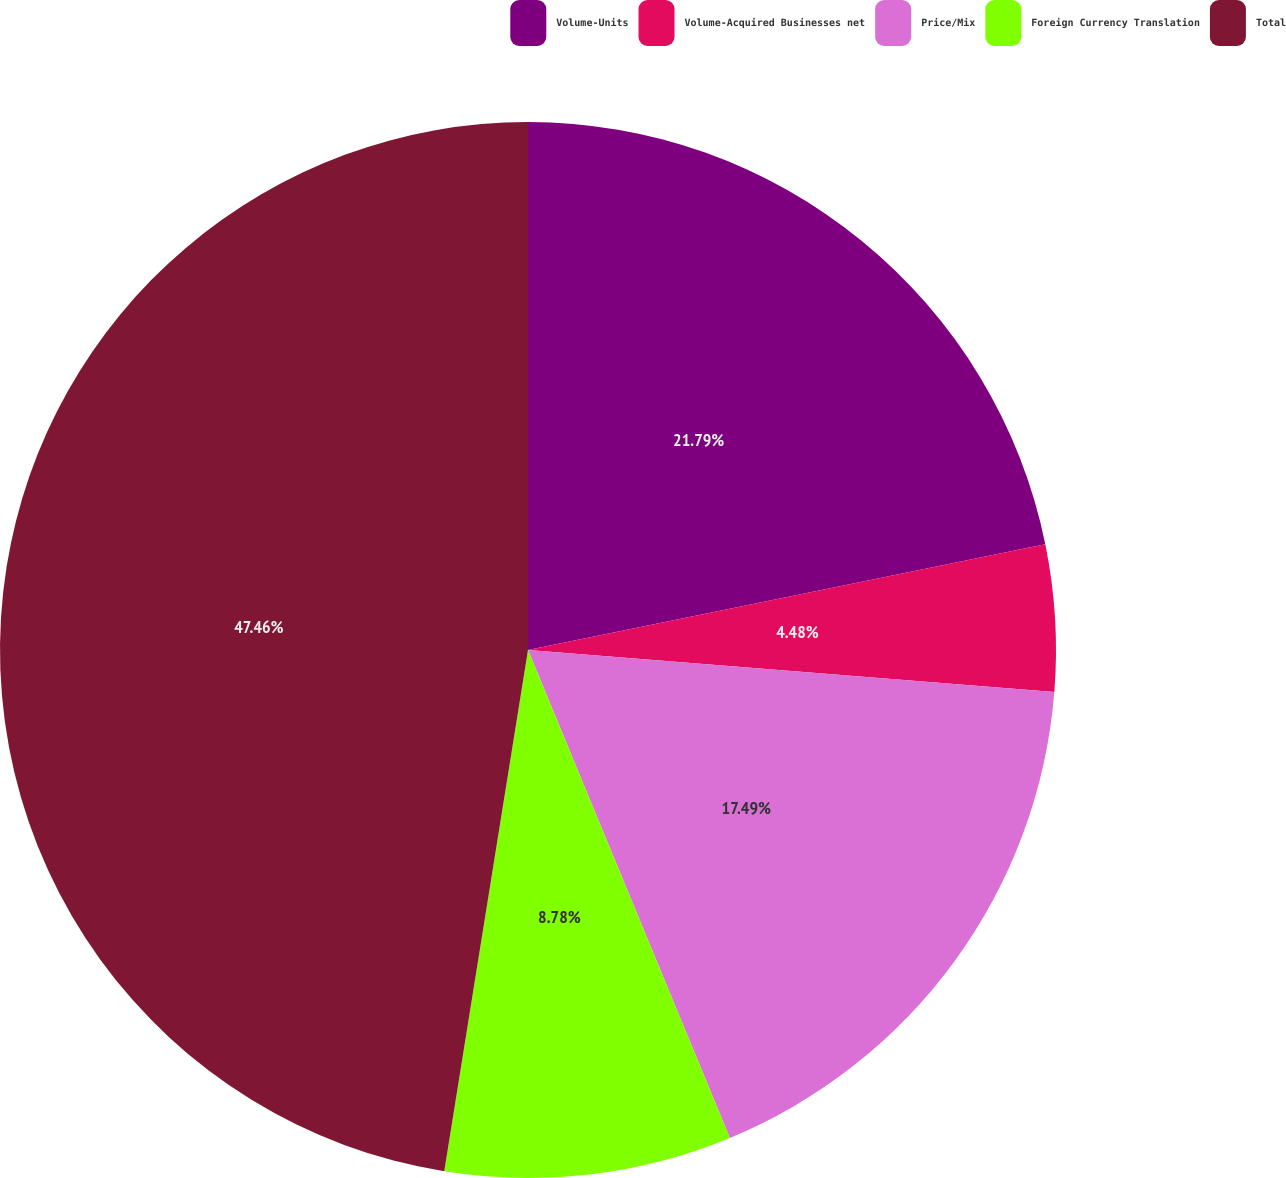Convert chart. <chart><loc_0><loc_0><loc_500><loc_500><pie_chart><fcel>Volume-Units<fcel>Volume-Acquired Businesses net<fcel>Price/Mix<fcel>Foreign Currency Translation<fcel>Total<nl><fcel>21.79%<fcel>4.48%<fcel>17.49%<fcel>8.78%<fcel>47.47%<nl></chart> 